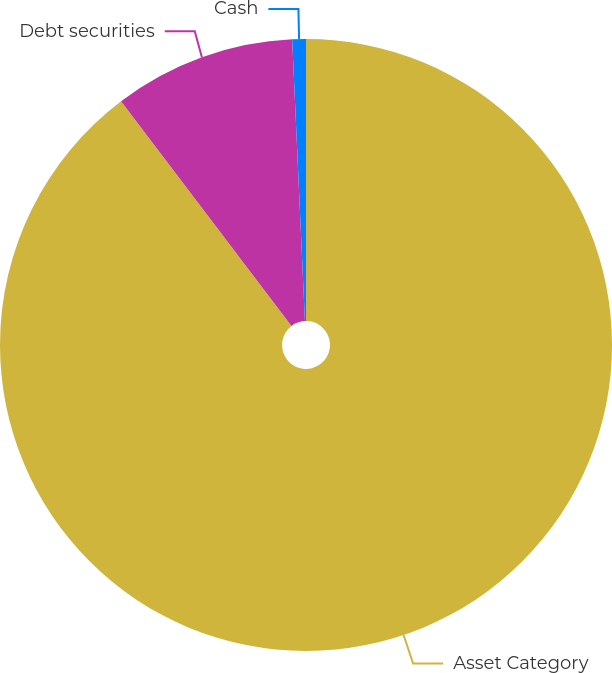Convert chart. <chart><loc_0><loc_0><loc_500><loc_500><pie_chart><fcel>Asset Category<fcel>Debt securities<fcel>Cash<nl><fcel>89.67%<fcel>9.61%<fcel>0.72%<nl></chart> 